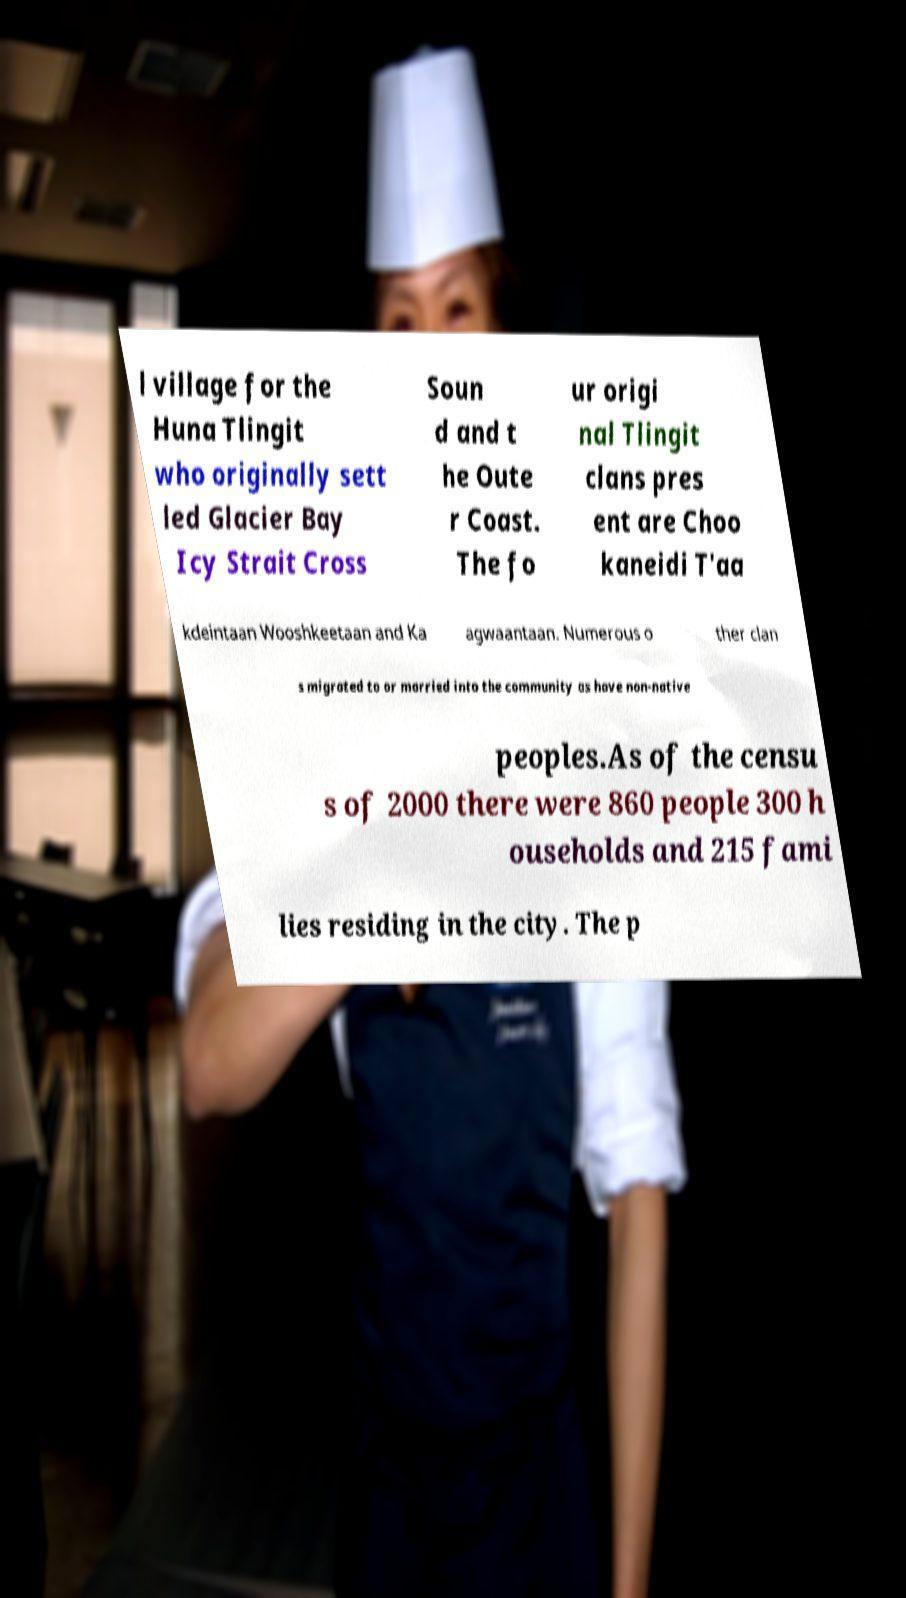For documentation purposes, I need the text within this image transcribed. Could you provide that? l village for the Huna Tlingit who originally sett led Glacier Bay Icy Strait Cross Soun d and t he Oute r Coast. The fo ur origi nal Tlingit clans pres ent are Choo kaneidi T'aa kdeintaan Wooshkeetaan and Ka agwaantaan. Numerous o ther clan s migrated to or married into the community as have non-native peoples.As of the censu s of 2000 there were 860 people 300 h ouseholds and 215 fami lies residing in the city. The p 